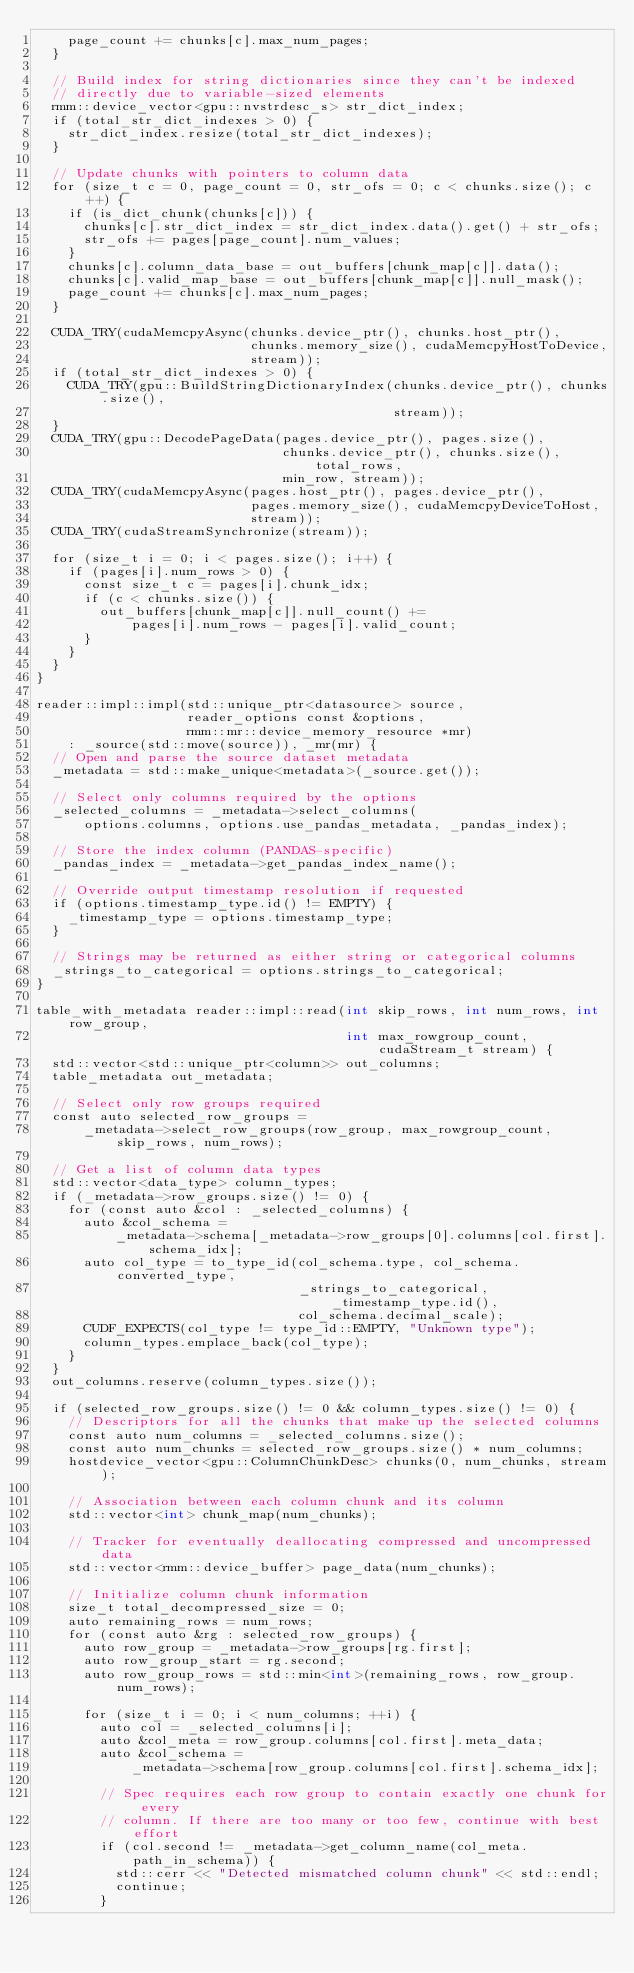<code> <loc_0><loc_0><loc_500><loc_500><_Cuda_>    page_count += chunks[c].max_num_pages;
  }

  // Build index for string dictionaries since they can't be indexed
  // directly due to variable-sized elements
  rmm::device_vector<gpu::nvstrdesc_s> str_dict_index;
  if (total_str_dict_indexes > 0) {
    str_dict_index.resize(total_str_dict_indexes);
  }

  // Update chunks with pointers to column data
  for (size_t c = 0, page_count = 0, str_ofs = 0; c < chunks.size(); c++) {
    if (is_dict_chunk(chunks[c])) {
      chunks[c].str_dict_index = str_dict_index.data().get() + str_ofs;
      str_ofs += pages[page_count].num_values;
    }
    chunks[c].column_data_base = out_buffers[chunk_map[c]].data();
    chunks[c].valid_map_base = out_buffers[chunk_map[c]].null_mask();
    page_count += chunks[c].max_num_pages;
  }

  CUDA_TRY(cudaMemcpyAsync(chunks.device_ptr(), chunks.host_ptr(),
                           chunks.memory_size(), cudaMemcpyHostToDevice,
                           stream));
  if (total_str_dict_indexes > 0) {
    CUDA_TRY(gpu::BuildStringDictionaryIndex(chunks.device_ptr(), chunks.size(),
                                             stream));
  }
  CUDA_TRY(gpu::DecodePageData(pages.device_ptr(), pages.size(),
                               chunks.device_ptr(), chunks.size(), total_rows,
                               min_row, stream));
  CUDA_TRY(cudaMemcpyAsync(pages.host_ptr(), pages.device_ptr(),
                           pages.memory_size(), cudaMemcpyDeviceToHost,
                           stream));
  CUDA_TRY(cudaStreamSynchronize(stream));

  for (size_t i = 0; i < pages.size(); i++) {
    if (pages[i].num_rows > 0) {
      const size_t c = pages[i].chunk_idx;
      if (c < chunks.size()) {
        out_buffers[chunk_map[c]].null_count() +=
            pages[i].num_rows - pages[i].valid_count;
      }
    }
  }
}

reader::impl::impl(std::unique_ptr<datasource> source,
                   reader_options const &options,
                   rmm::mr::device_memory_resource *mr)
    : _source(std::move(source)), _mr(mr) {
  // Open and parse the source dataset metadata
  _metadata = std::make_unique<metadata>(_source.get());

  // Select only columns required by the options
  _selected_columns = _metadata->select_columns(
      options.columns, options.use_pandas_metadata, _pandas_index);

  // Store the index column (PANDAS-specific)
  _pandas_index = _metadata->get_pandas_index_name();

  // Override output timestamp resolution if requested
  if (options.timestamp_type.id() != EMPTY) {
    _timestamp_type = options.timestamp_type;
  }

  // Strings may be returned as either string or categorical columns
  _strings_to_categorical = options.strings_to_categorical;
}

table_with_metadata reader::impl::read(int skip_rows, int num_rows, int row_group,
                                       int max_rowgroup_count, cudaStream_t stream) {
  std::vector<std::unique_ptr<column>> out_columns;
  table_metadata out_metadata;

  // Select only row groups required
  const auto selected_row_groups =
      _metadata->select_row_groups(row_group, max_rowgroup_count, skip_rows, num_rows);

  // Get a list of column data types
  std::vector<data_type> column_types;
  if (_metadata->row_groups.size() != 0) {
    for (const auto &col : _selected_columns) {
      auto &col_schema =
          _metadata->schema[_metadata->row_groups[0].columns[col.first].schema_idx];
      auto col_type = to_type_id(col_schema.type, col_schema.converted_type,
                                 _strings_to_categorical, _timestamp_type.id(),
                                 col_schema.decimal_scale);
      CUDF_EXPECTS(col_type != type_id::EMPTY, "Unknown type");
      column_types.emplace_back(col_type);
    }
  }
  out_columns.reserve(column_types.size());

  if (selected_row_groups.size() != 0 && column_types.size() != 0) {
    // Descriptors for all the chunks that make up the selected columns
    const auto num_columns = _selected_columns.size();
    const auto num_chunks = selected_row_groups.size() * num_columns;
    hostdevice_vector<gpu::ColumnChunkDesc> chunks(0, num_chunks, stream);

    // Association between each column chunk and its column
    std::vector<int> chunk_map(num_chunks);

    // Tracker for eventually deallocating compressed and uncompressed data
    std::vector<rmm::device_buffer> page_data(num_chunks);

    // Initialize column chunk information
    size_t total_decompressed_size = 0;
    auto remaining_rows = num_rows;
    for (const auto &rg : selected_row_groups) {
      auto row_group = _metadata->row_groups[rg.first];
      auto row_group_start = rg.second;
      auto row_group_rows = std::min<int>(remaining_rows, row_group.num_rows);

      for (size_t i = 0; i < num_columns; ++i) {
        auto col = _selected_columns[i];
        auto &col_meta = row_group.columns[col.first].meta_data;
        auto &col_schema =
            _metadata->schema[row_group.columns[col.first].schema_idx];

        // Spec requires each row group to contain exactly one chunk for every
        // column. If there are too many or too few, continue with best effort
        if (col.second != _metadata->get_column_name(col_meta.path_in_schema)) {
          std::cerr << "Detected mismatched column chunk" << std::endl;
          continue;
        }</code> 